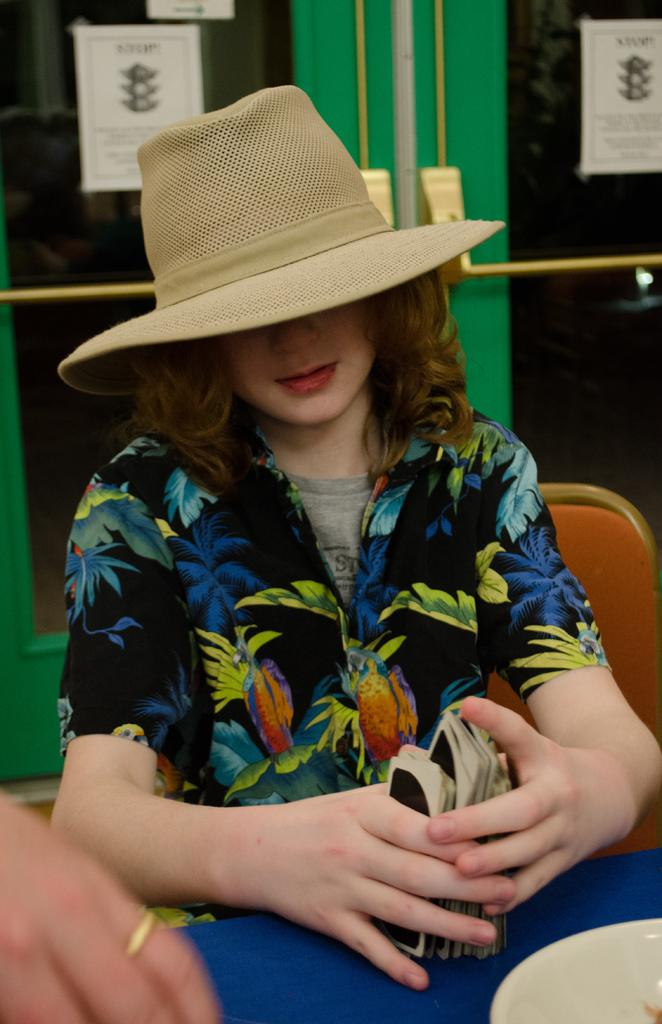What is the person in the image doing? The person is sitting in the image. What is the person wearing on their upper body? The person is wearing a floral shirt. What type of headwear is the person wearing? The person is wearing a hat. What is the person holding in her hand? The person is holding cards in her hand. What can be seen behind the person? There is a door visible behind the person. What type of thrill can be seen on the person's face in the image? There is no indication of a thrill or any specific emotion on the person's face in the image. 